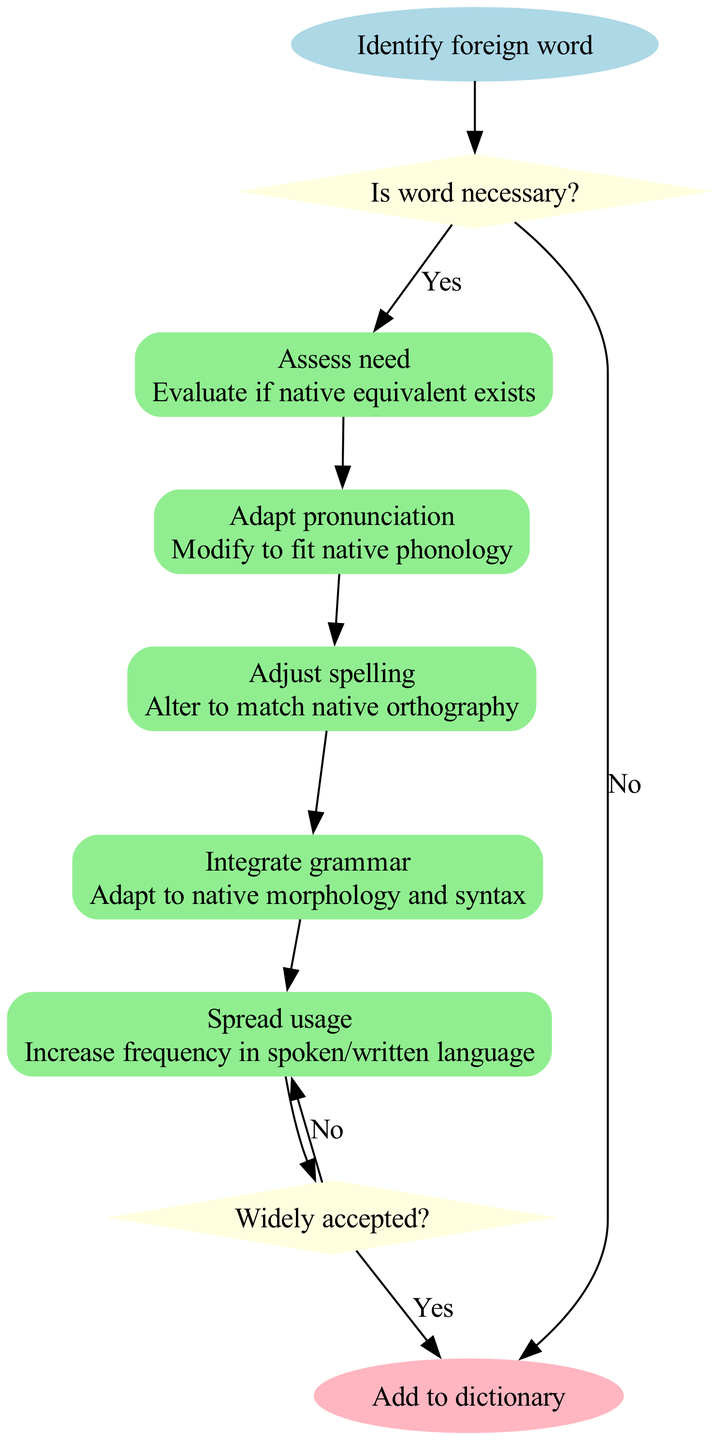What is the starting point of the process? The starting point of the process is defined by the 'startNode' in the diagram, which is "Identify foreign word".
Answer: Identify foreign word How many processes are included in the diagram? By counting the "processes" listed in the data, we see five distinct processes.
Answer: 5 What happens if the answer to "Is word necessary?" is "No"? According to the edge in the diagram, if the answer is "No", the process ends.
Answer: End process What is the last process before adding a word to the dictionary? The last process before adding a word to the dictionary is 'Spread usage'.
Answer: Spread usage What is the question at the first decision point? The first decision point asks the question "Is word necessary?".
Answer: Is word necessary? If the word is deemed unnecessary, what is the next step? The next step would be to end the process, as indicated in the diagram if the answer is "No".
Answer: End process How does "Spread usage" connect to the next decision point? "Spread usage" connects directly to the second decision point, indicated by an edge leading to 'decision_1'.
Answer: To decision point 2 What is required if the word is widely accepted? If the word is widely accepted, it leads to "Add to dictionary" as per the flow from the second decision point.
Answer: Add to dictionary What node follows "Adapt pronunciation"? Following "Adapt pronunciation", the next node in the process is "Adjust spelling".
Answer: Adjust spelling 